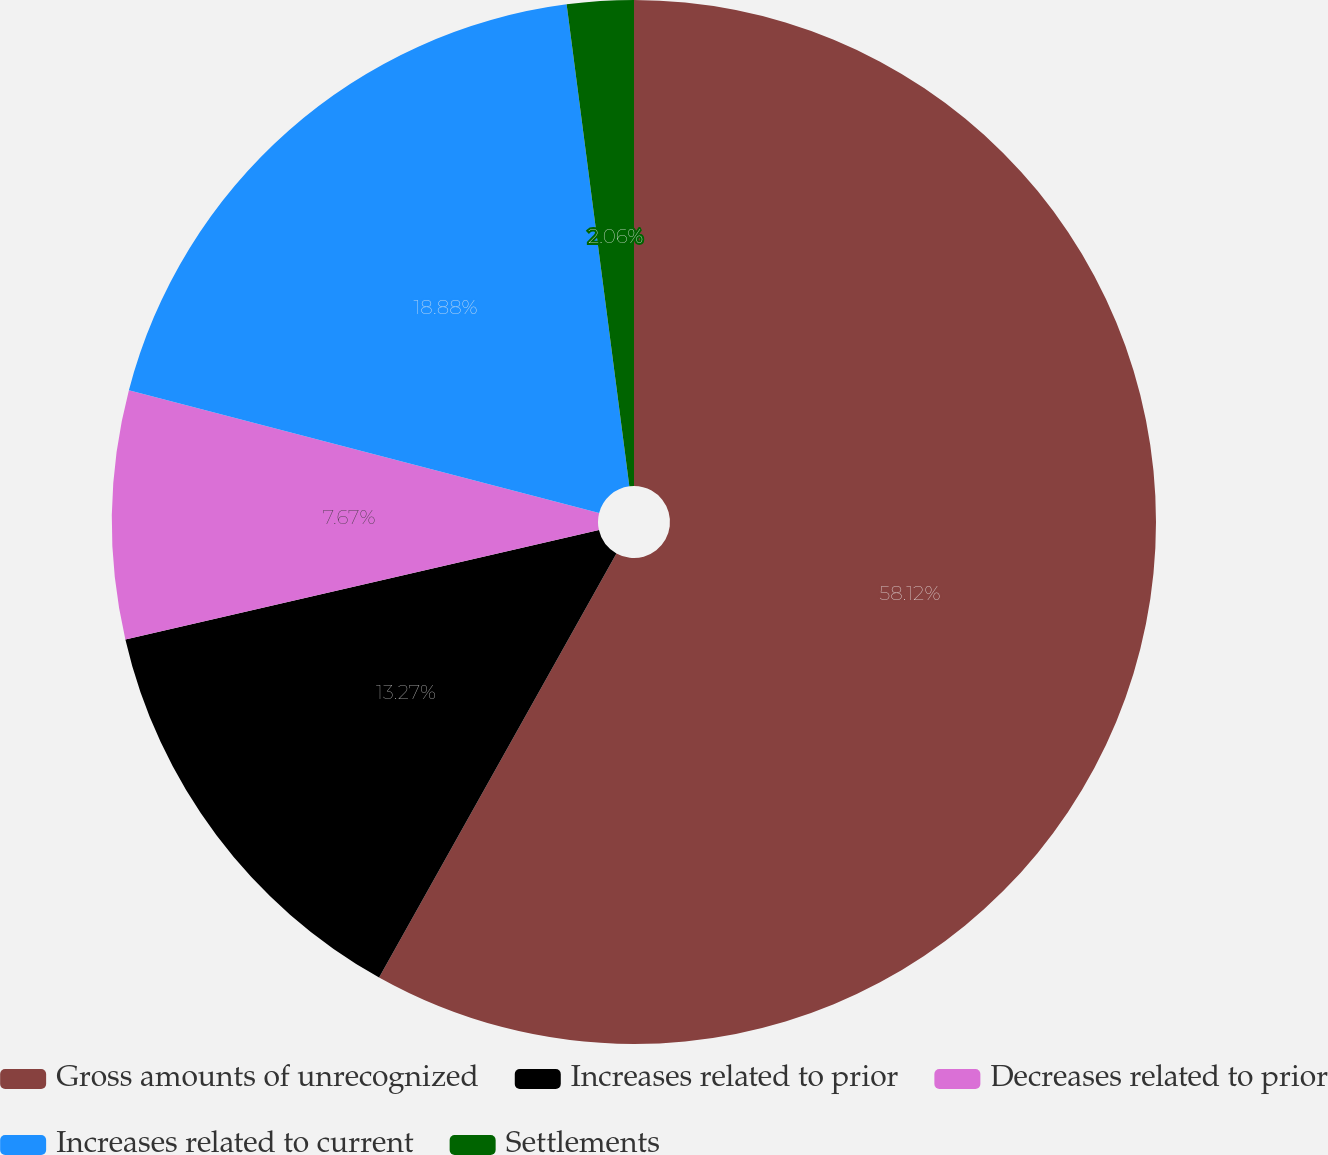Convert chart to OTSL. <chart><loc_0><loc_0><loc_500><loc_500><pie_chart><fcel>Gross amounts of unrecognized<fcel>Increases related to prior<fcel>Decreases related to prior<fcel>Increases related to current<fcel>Settlements<nl><fcel>58.12%<fcel>13.27%<fcel>7.67%<fcel>18.88%<fcel>2.06%<nl></chart> 